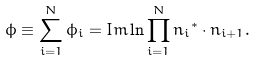<formula> <loc_0><loc_0><loc_500><loc_500>\phi \equiv \sum ^ { N } _ { i = 1 } \phi _ { i } = I m \ln \prod ^ { N } _ { i = 1 } { n _ { i } } ^ { * } \cdot { n } _ { i + 1 } .</formula> 